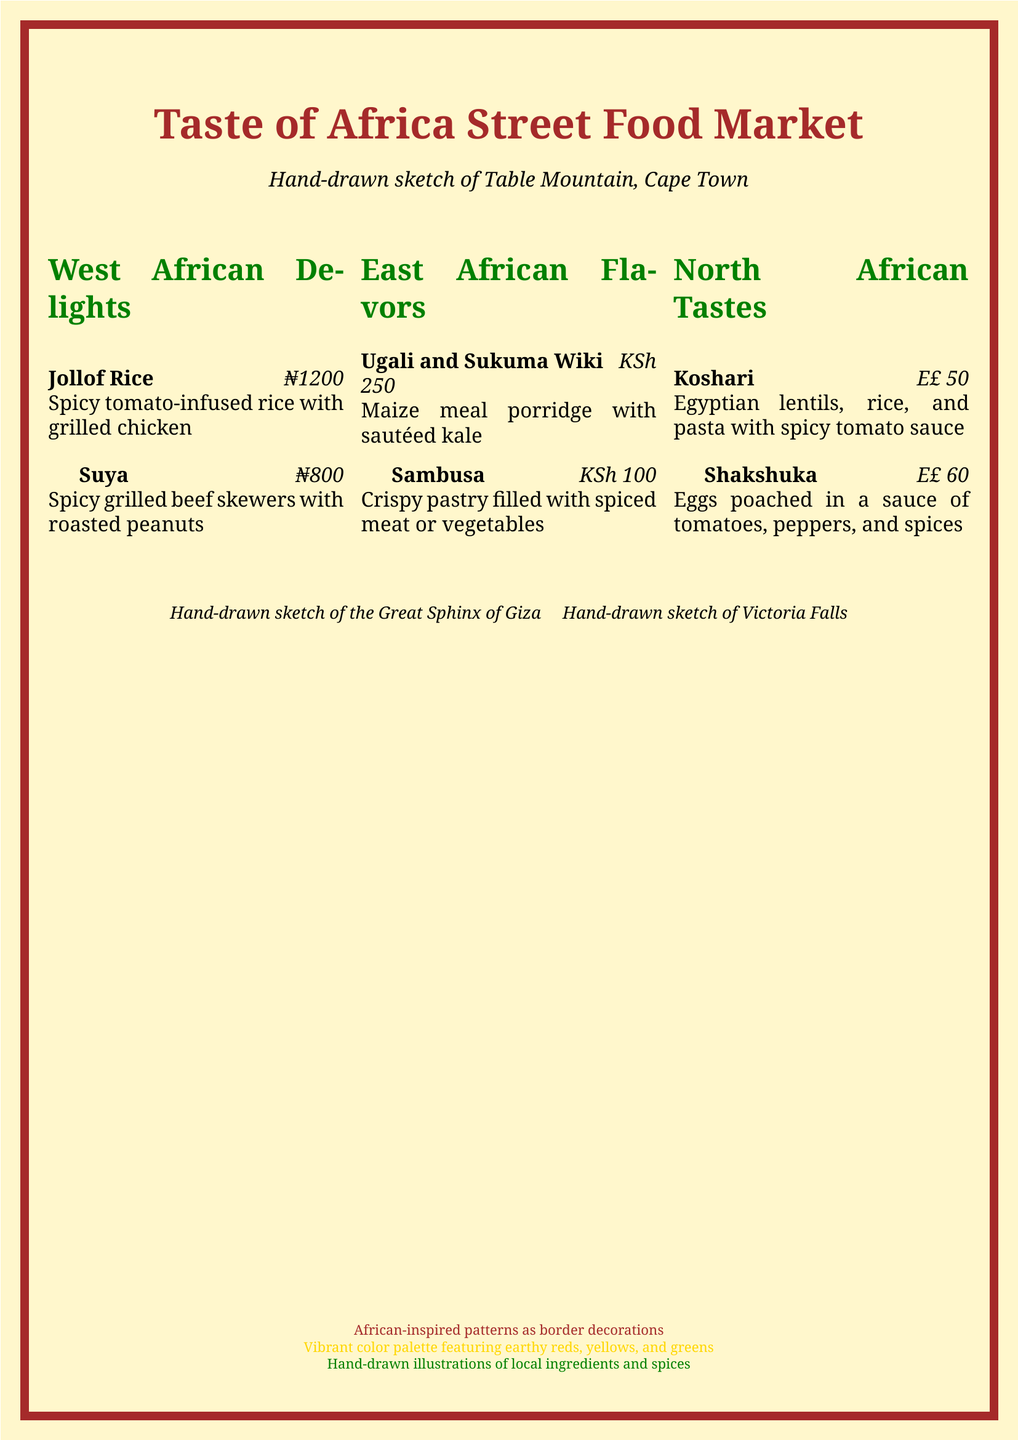What is the name of the first dish listed in West African Delights? The first dish listed in West African Delights is Jollof Rice.
Answer: Jollof Rice How much does Suya cost? The cost of Suya is specified in the document as ₦800.
Answer: ₦800 What is the main ingredient in Ugali? Ugali is primarily made from maize meal porridge.
Answer: Maize meal porridge What are the ingredients in Koshari? Koshari consists of Egyptian lentils, rice, and pasta.
Answer: Lentils, rice, and pasta How many sections are there in the menu? The menu consists of three sections: West African Delights, East African Flavors, and North African Tastes.
Answer: Three What sketch is mentioned above the menu title? The sketch above the menu title is of Table Mountain, Cape Town.
Answer: Table Mountain Which East African dish is a crispy pastry? The crispy pastry dish listed under East African Flavors is Sambusa.
Answer: Sambusa What color is the border decoration specified in the document? The border decoration is specified to have African-inspired patterns.
Answer: African-inspired patterns 